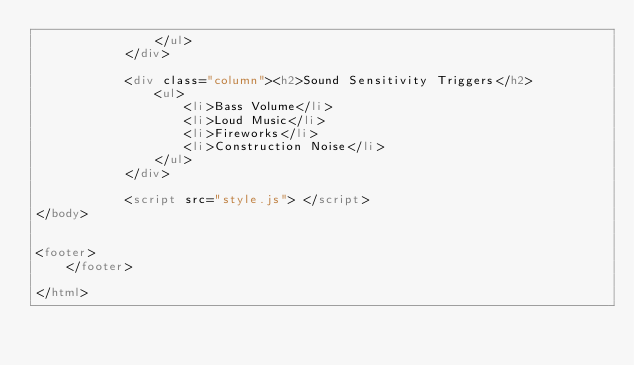Convert code to text. <code><loc_0><loc_0><loc_500><loc_500><_HTML_>                </ul>
            </div> 
                     
            <div class="column"><h2>Sound Sensitivity Triggers</h2>
                <ul>
                    <li>Bass Volume</li>
                    <li>Loud Music</li>
                    <li>Fireworks</li>
                    <li>Construction Noise</li>
                </ul>
            </div>
   
            <script src="style.js"> </script>
</body>


<footer>
    </footer>

</html></code> 